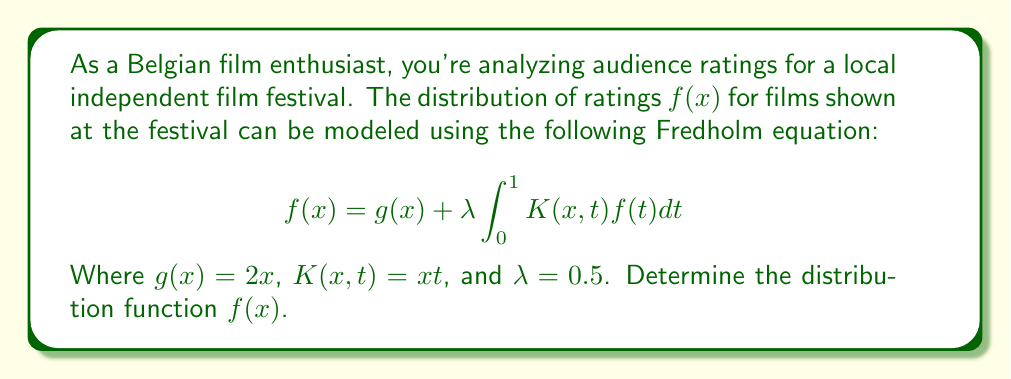Show me your answer to this math problem. To solve this Fredholm equation, we'll follow these steps:

1) First, we substitute the given functions into the equation:
   $$f(x) = 2x + 0.5 \int_0^1 xt f(t)dt$$

2) Let's denote the integral as $I$:
   $$I = \int_0^1 t f(t)dt$$
   
   This is a constant (independent of x).

3) Now our equation becomes:
   $$f(x) = 2x + 0.5x I$$

4) To find $I$, we integrate both sides of this equation from 0 to 1:
   $$\int_0^1 f(x)dx = \int_0^1 (2x + 0.5x I)dx$$
   
   $$I = 1 + 0.25I$$

5) Solving for $I$:
   $$0.75I = 1$$
   $$I = \frac{4}{3}$$

6) Now we can substitute this back into our equation for $f(x)$:
   $$f(x) = 2x + 0.5x \cdot \frac{4}{3}$$
   
   $$f(x) = 2x + \frac{2x}{3}$$

7) Simplifying:
   $$f(x) = \frac{6x}{3} + \frac{2x}{3} = \frac{8x}{3}$$

Therefore, the distribution function $f(x)$ is $\frac{8x}{3}$.
Answer: $f(x) = \frac{8x}{3}$ 